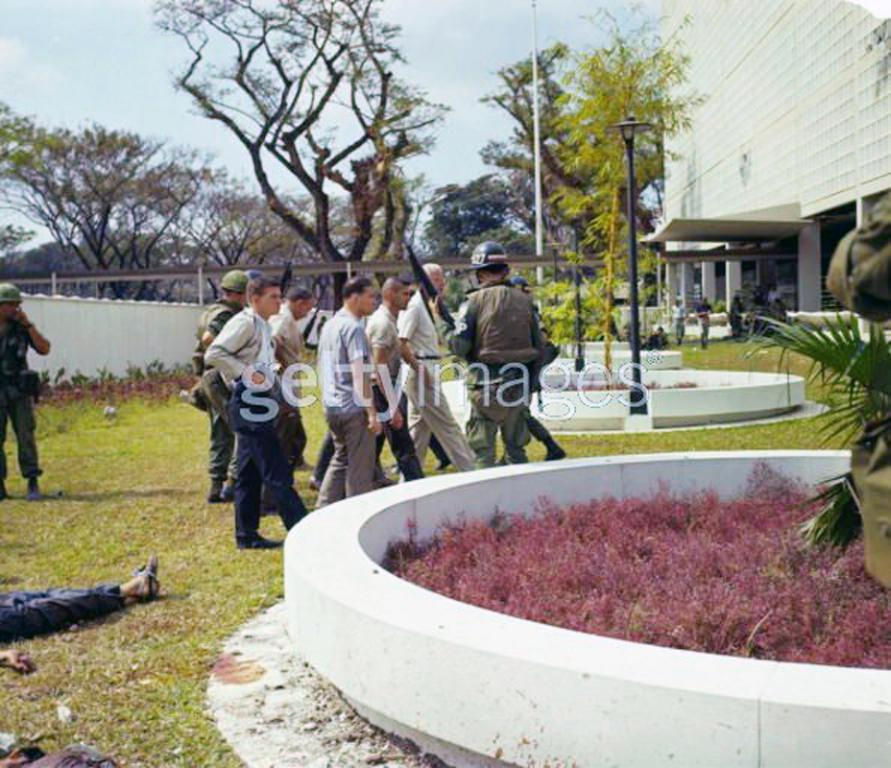Who or what can be seen in the image? There are people in the image. What structures are present in the image? There are poles, buildings, and trees in the image. What else can be found in the image? There are objects in the image. What part of the natural environment is visible in the image? The sky is visible in the image. What type of vessel is being smashed by the people in the image? There is no vessel present in the image, nor are the people smashing anything. 